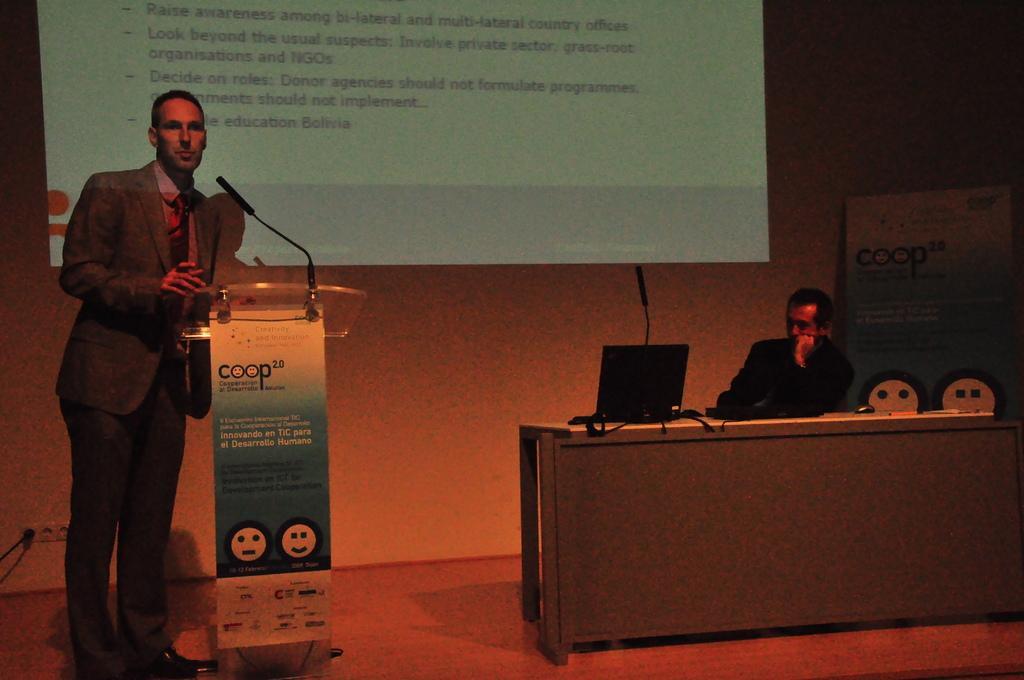Could you give a brief overview of what you see in this image? This picture is taken inside the conference hall. In this image, on the left side, we can see a man standing beside the table. On that table, we can see a microphone. On the right side, we can also see a man sitting on the chair in front of the table, on that table, we can see a laptop, mouse and electrical wires. On the right side, we can also see a hoarding. In the background, we can see a screen. On the left side bottom, we can also see a switch board and electric wires. 